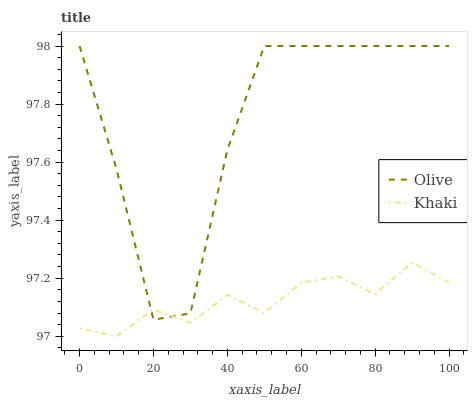Does Khaki have the minimum area under the curve?
Answer yes or no. Yes. Does Olive have the maximum area under the curve?
Answer yes or no. Yes. Does Khaki have the maximum area under the curve?
Answer yes or no. No. Is Khaki the smoothest?
Answer yes or no. Yes. Is Olive the roughest?
Answer yes or no. Yes. Is Khaki the roughest?
Answer yes or no. No. Does Olive have the highest value?
Answer yes or no. Yes. Does Khaki have the highest value?
Answer yes or no. No. Does Olive intersect Khaki?
Answer yes or no. Yes. Is Olive less than Khaki?
Answer yes or no. No. Is Olive greater than Khaki?
Answer yes or no. No. 